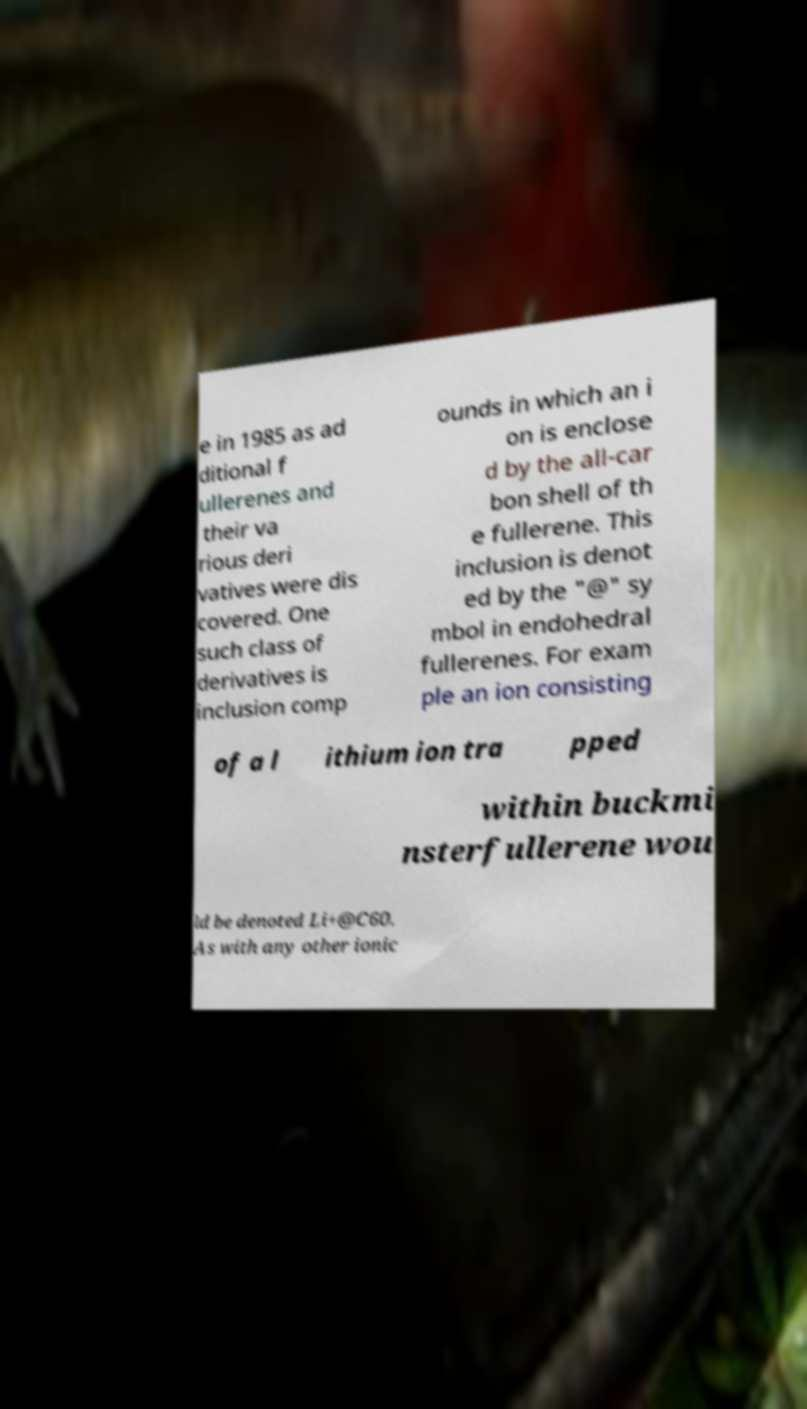For documentation purposes, I need the text within this image transcribed. Could you provide that? e in 1985 as ad ditional f ullerenes and their va rious deri vatives were dis covered. One such class of derivatives is inclusion comp ounds in which an i on is enclose d by the all-car bon shell of th e fullerene. This inclusion is denot ed by the "@" sy mbol in endohedral fullerenes. For exam ple an ion consisting of a l ithium ion tra pped within buckmi nsterfullerene wou ld be denoted Li+@C60. As with any other ionic 